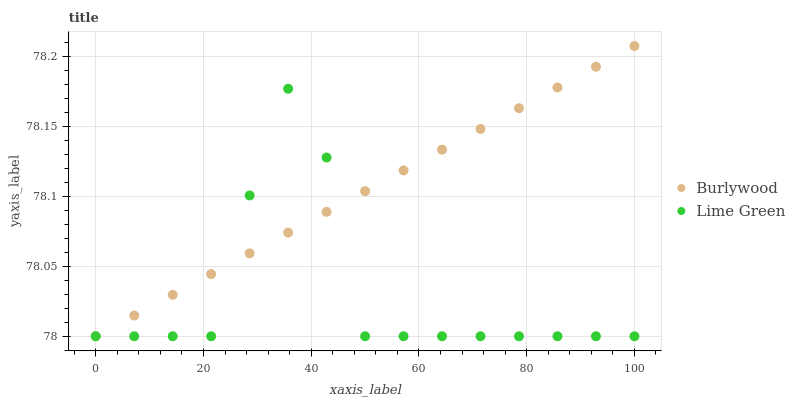Does Lime Green have the minimum area under the curve?
Answer yes or no. Yes. Does Burlywood have the maximum area under the curve?
Answer yes or no. Yes. Does Lime Green have the maximum area under the curve?
Answer yes or no. No. Is Burlywood the smoothest?
Answer yes or no. Yes. Is Lime Green the roughest?
Answer yes or no. Yes. Is Lime Green the smoothest?
Answer yes or no. No. Does Burlywood have the lowest value?
Answer yes or no. Yes. Does Burlywood have the highest value?
Answer yes or no. Yes. Does Lime Green have the highest value?
Answer yes or no. No. Does Lime Green intersect Burlywood?
Answer yes or no. Yes. Is Lime Green less than Burlywood?
Answer yes or no. No. Is Lime Green greater than Burlywood?
Answer yes or no. No. 